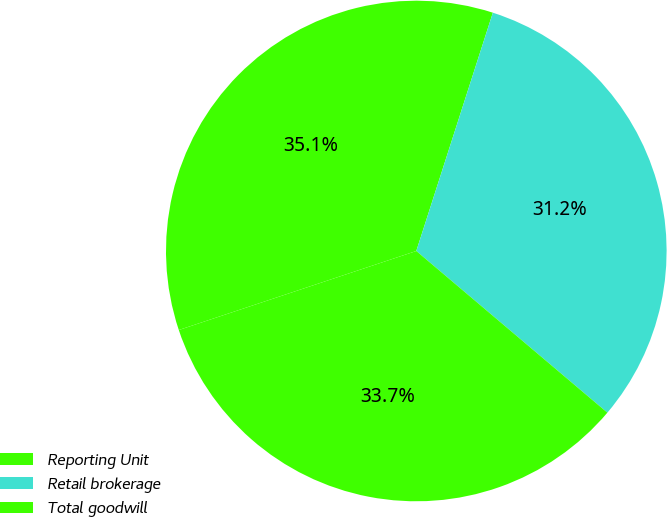Convert chart to OTSL. <chart><loc_0><loc_0><loc_500><loc_500><pie_chart><fcel>Reporting Unit<fcel>Retail brokerage<fcel>Total goodwill<nl><fcel>35.06%<fcel>31.23%<fcel>33.71%<nl></chart> 